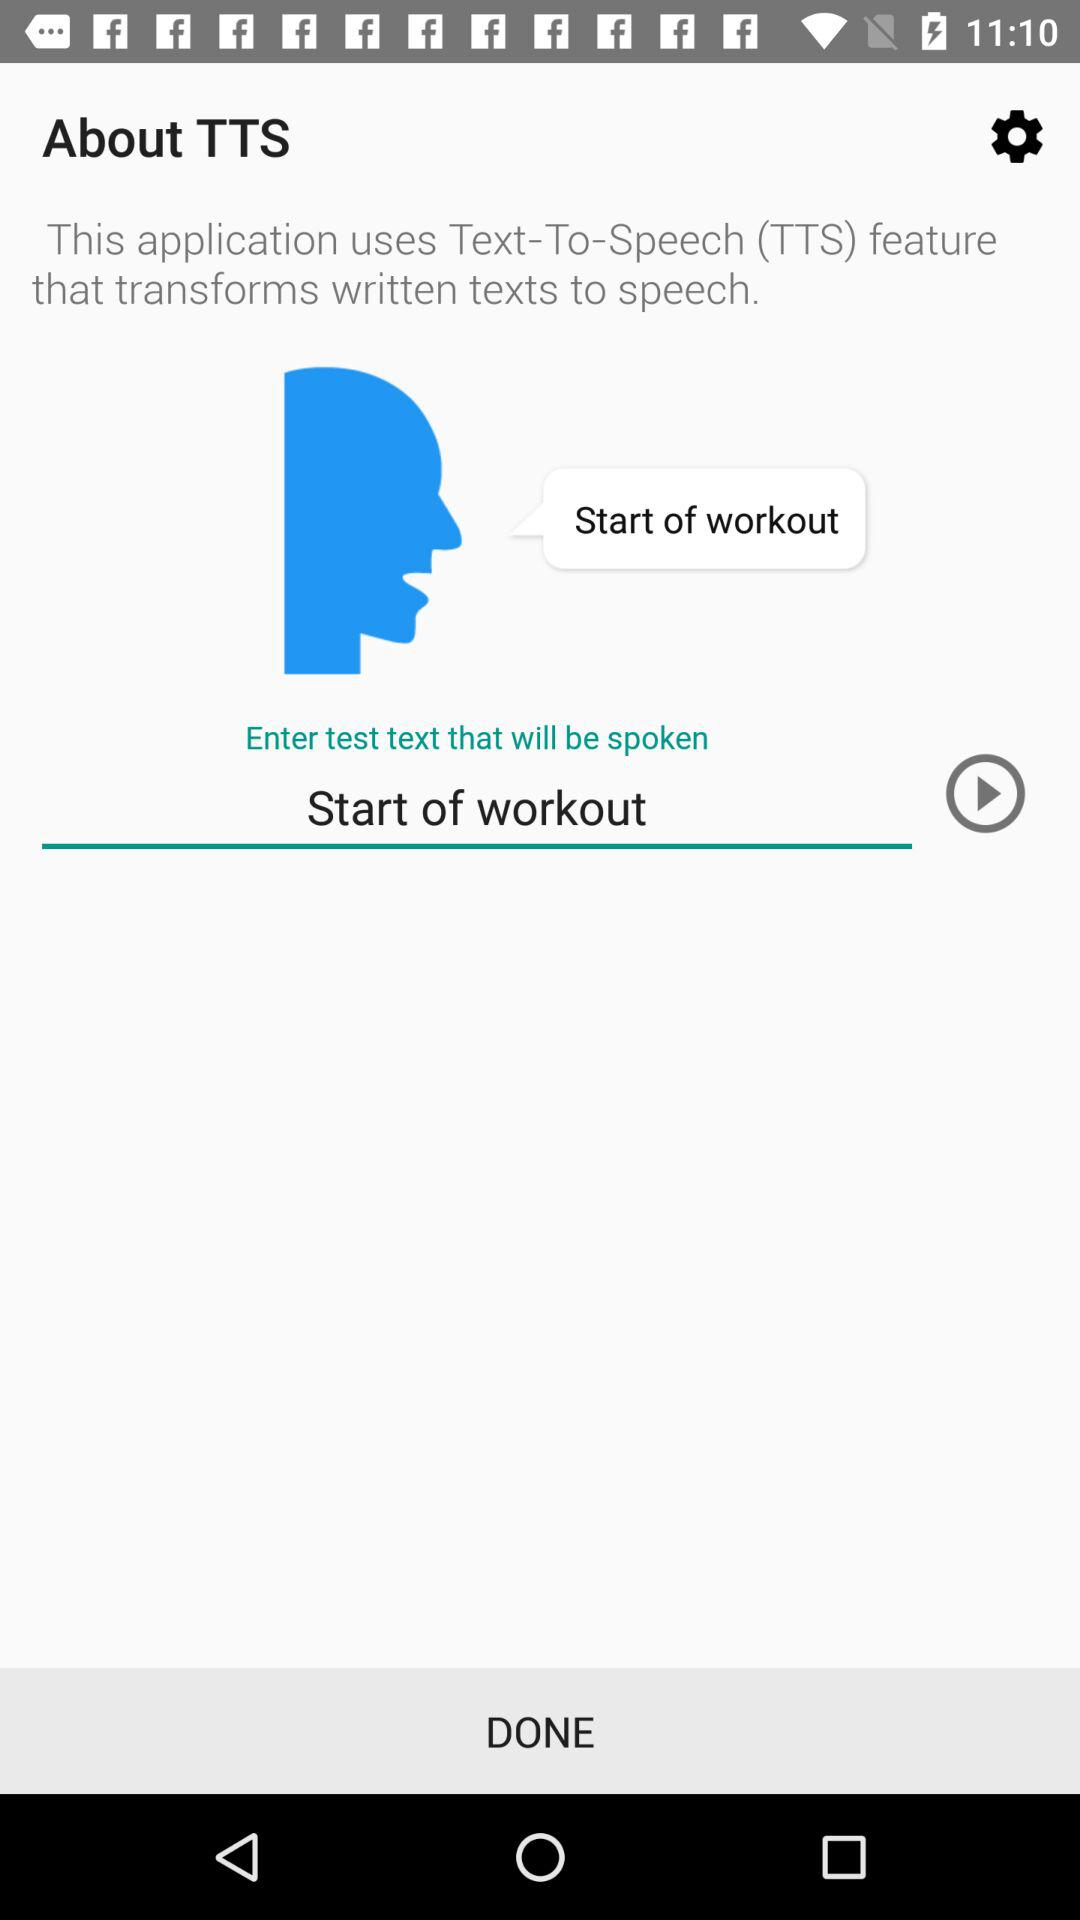What is the input text? The input text is "Start of workout". 